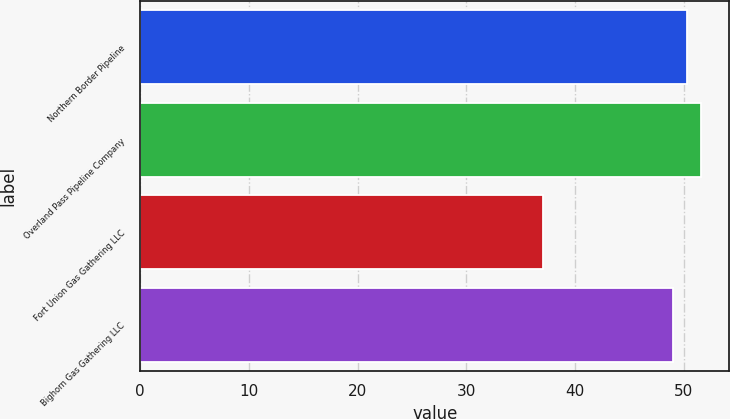Convert chart to OTSL. <chart><loc_0><loc_0><loc_500><loc_500><bar_chart><fcel>Northern Border Pipeline<fcel>Overland Pass Pipeline Company<fcel>Fort Union Gas Gathering LLC<fcel>Bighorn Gas Gathering LLC<nl><fcel>50.3<fcel>51.6<fcel>37<fcel>49<nl></chart> 